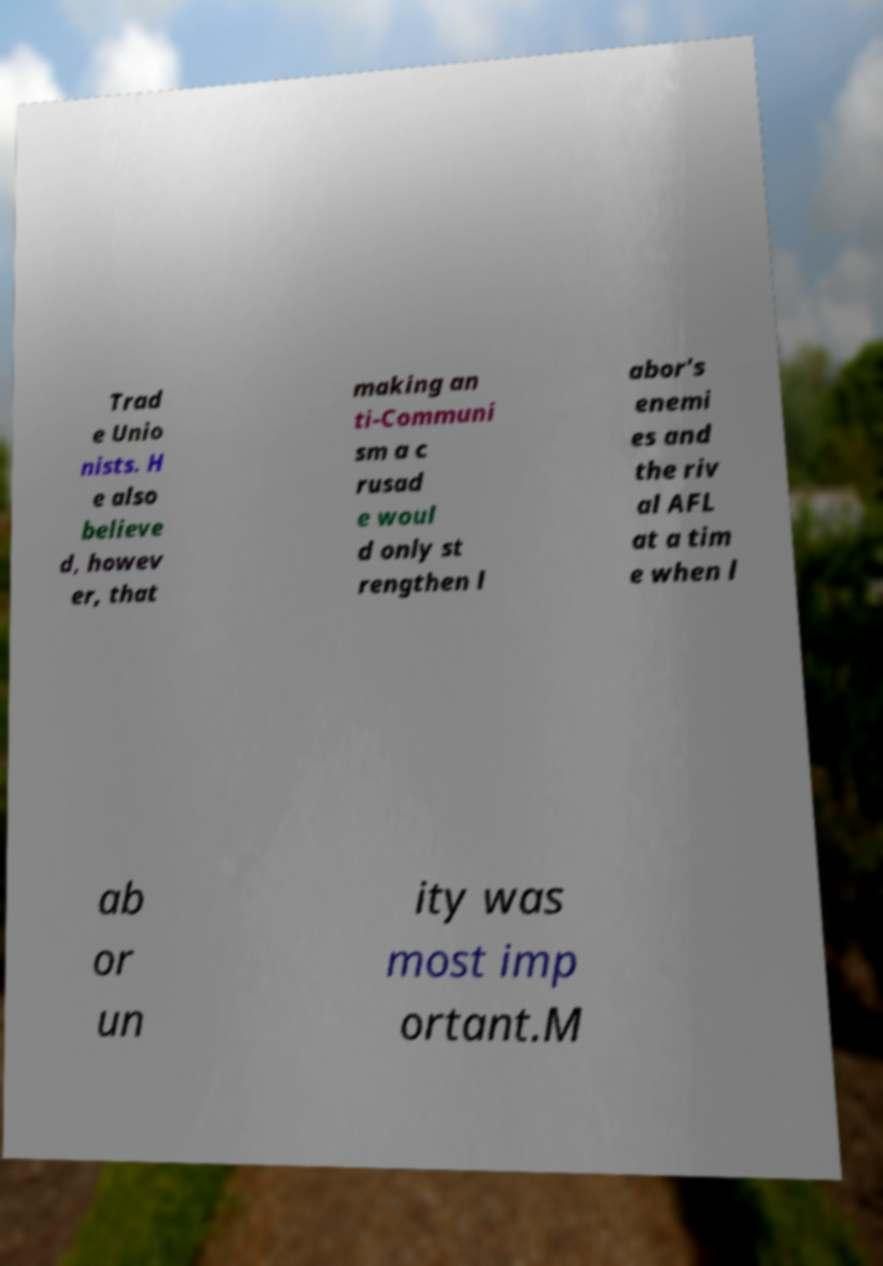Please identify and transcribe the text found in this image. Trad e Unio nists. H e also believe d, howev er, that making an ti-Communi sm a c rusad e woul d only st rengthen l abor's enemi es and the riv al AFL at a tim e when l ab or un ity was most imp ortant.M 